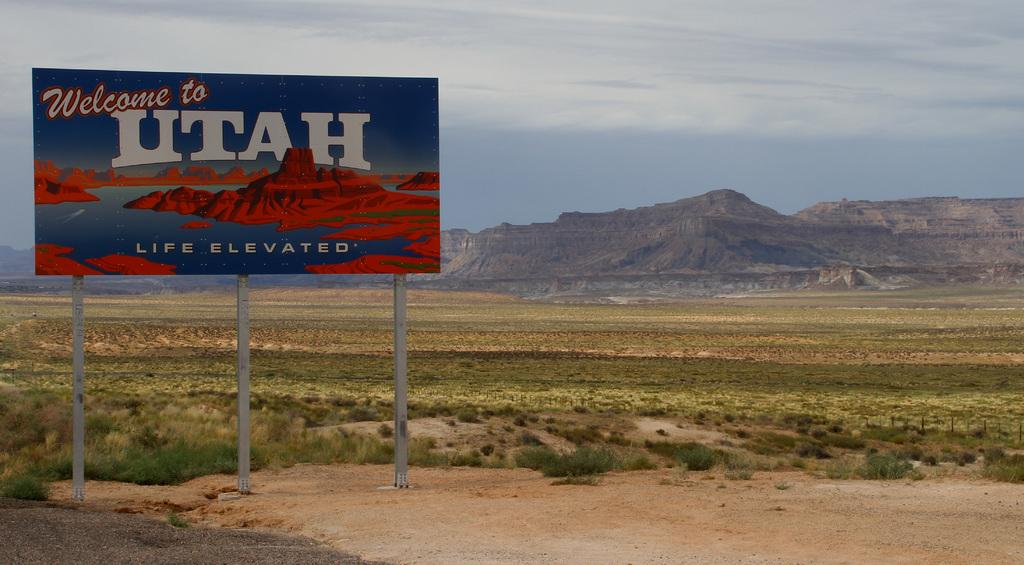<image>
Describe the image concisely. A billboard saying Welcome to Utah sits on a flat strip of dirt surrounded by dry looking grass and mountains in the background. 